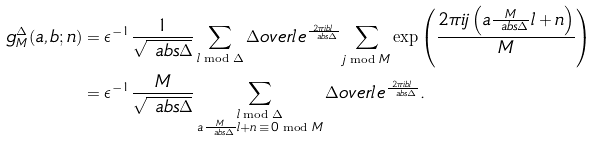Convert formula to latex. <formula><loc_0><loc_0><loc_500><loc_500>g _ { M } ^ { \Delta } ( a , b ; n ) & = \epsilon ^ { - 1 } \frac { 1 } { \sqrt { \ a b s { \Delta } } } \sum _ { l \bmod \Delta } \Delta o v e r { l } \, e ^ { \frac { 2 \pi i b l } { \ a b s { \Delta } } } \sum _ { j \bmod M } \exp \left ( { \frac { 2 \pi i j \left ( a \frac { M } { \ a b s { \Delta } } l + n \right ) } { M } } \right ) \\ & = \epsilon ^ { - 1 } \frac { M } { \sqrt { \ a b s { \Delta } } } \sum _ { \substack { l \bmod \Delta \\ a \frac { M } { \ a b s \Delta } l + n \, \equiv \, 0 \bmod M } } \Delta o v e r { l } \, e ^ { \frac { 2 \pi i b l } { \ a b s { \Delta } } } .</formula> 